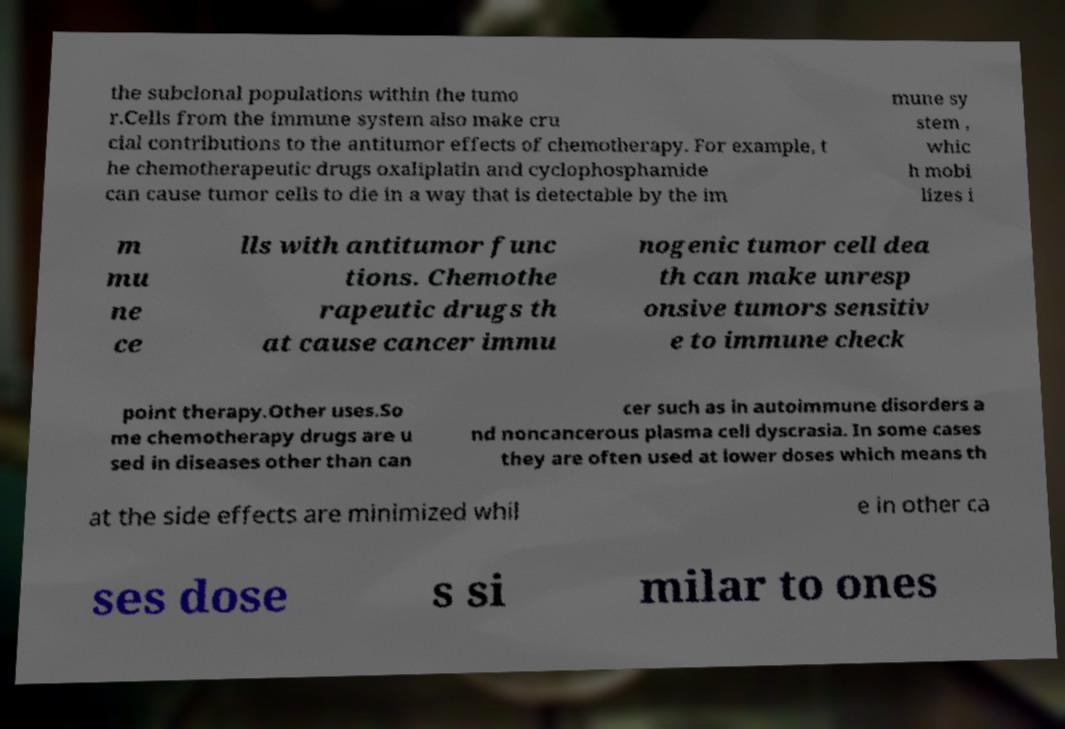Can you read and provide the text displayed in the image?This photo seems to have some interesting text. Can you extract and type it out for me? the subclonal populations within the tumo r.Cells from the immune system also make cru cial contributions to the antitumor effects of chemotherapy. For example, t he chemotherapeutic drugs oxaliplatin and cyclophosphamide can cause tumor cells to die in a way that is detectable by the im mune sy stem , whic h mobi lizes i m mu ne ce lls with antitumor func tions. Chemothe rapeutic drugs th at cause cancer immu nogenic tumor cell dea th can make unresp onsive tumors sensitiv e to immune check point therapy.Other uses.So me chemotherapy drugs are u sed in diseases other than can cer such as in autoimmune disorders a nd noncancerous plasma cell dyscrasia. In some cases they are often used at lower doses which means th at the side effects are minimized whil e in other ca ses dose s si milar to ones 